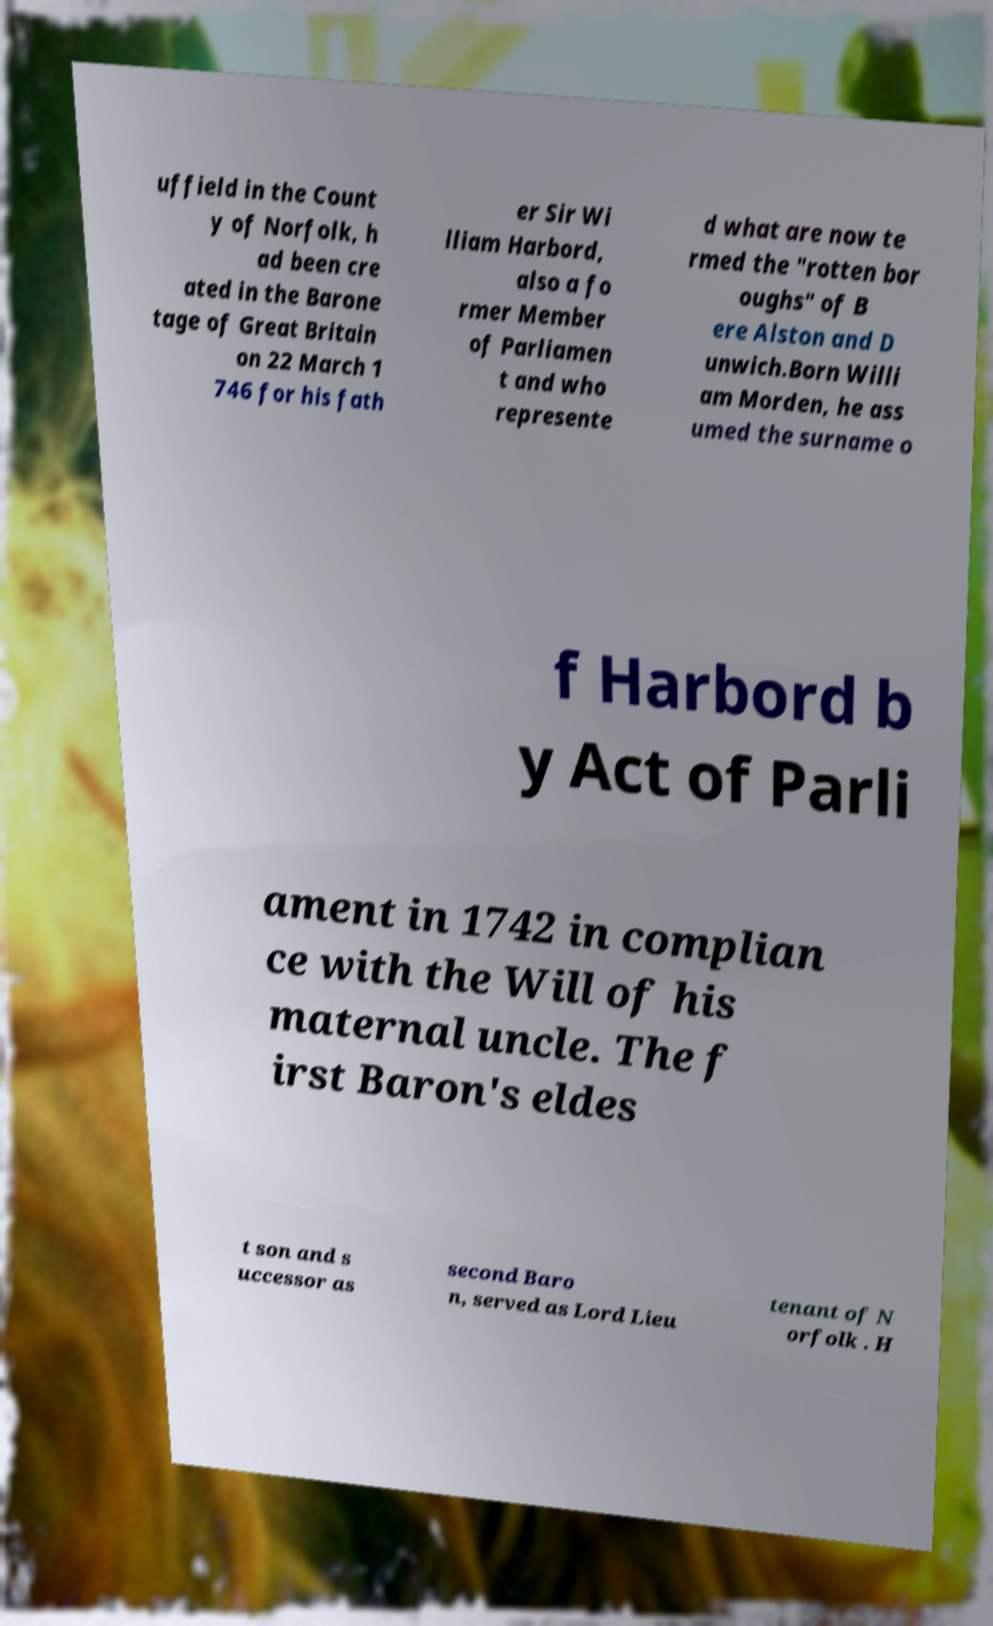There's text embedded in this image that I need extracted. Can you transcribe it verbatim? uffield in the Count y of Norfolk, h ad been cre ated in the Barone tage of Great Britain on 22 March 1 746 for his fath er Sir Wi lliam Harbord, also a fo rmer Member of Parliamen t and who represente d what are now te rmed the "rotten bor oughs" of B ere Alston and D unwich.Born Willi am Morden, he ass umed the surname o f Harbord b y Act of Parli ament in 1742 in complian ce with the Will of his maternal uncle. The f irst Baron's eldes t son and s uccessor as second Baro n, served as Lord Lieu tenant of N orfolk . H 